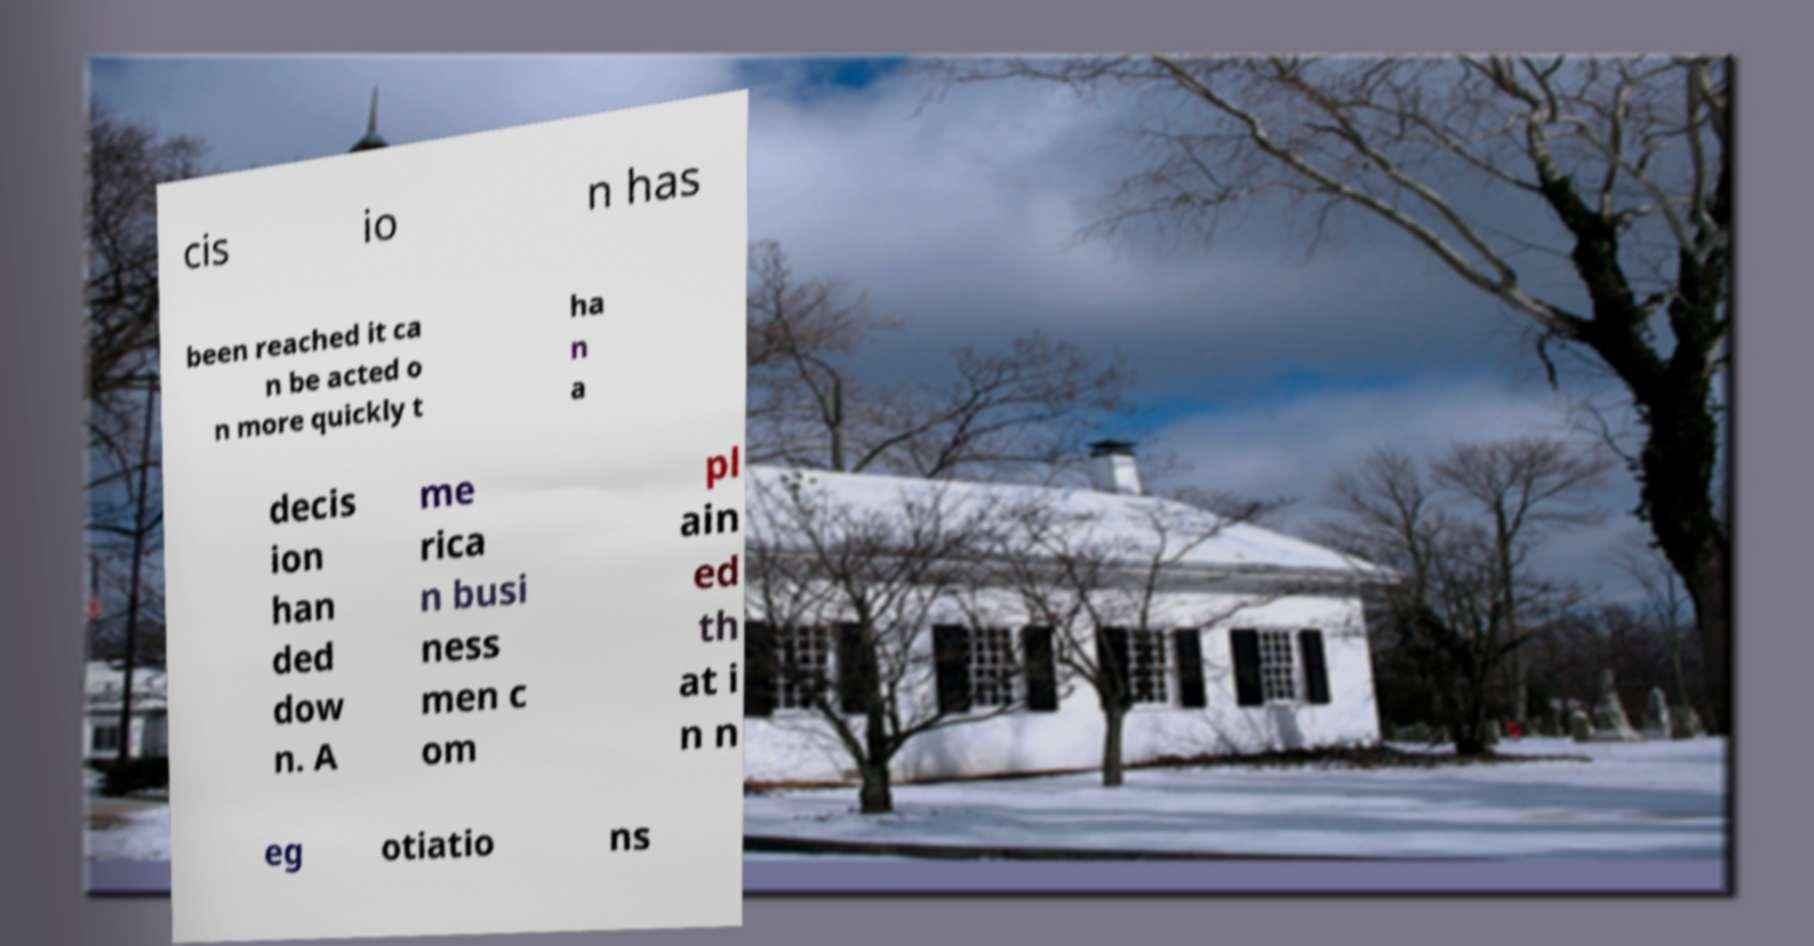Could you extract and type out the text from this image? cis io n has been reached it ca n be acted o n more quickly t ha n a decis ion han ded dow n. A me rica n busi ness men c om pl ain ed th at i n n eg otiatio ns 